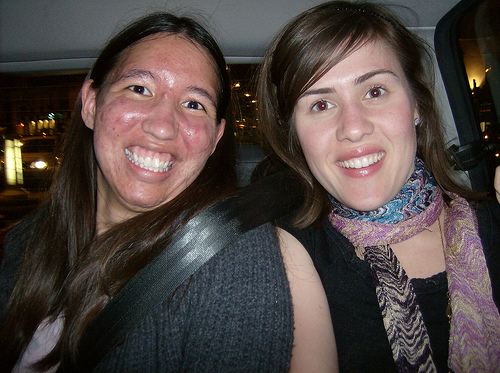<image>
Is there a lady on the lady? No. The lady is not positioned on the lady. They may be near each other, but the lady is not supported by or resting on top of the lady. 